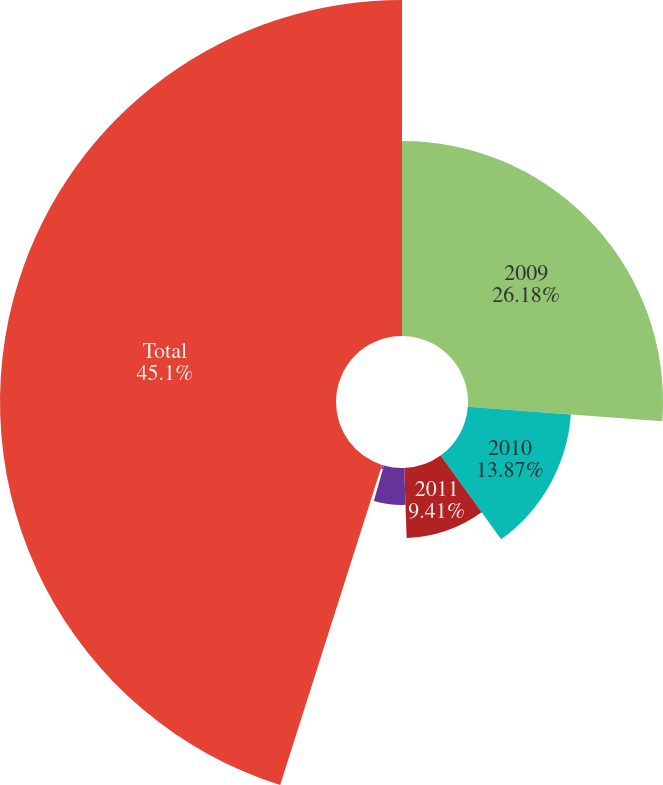Convert chart. <chart><loc_0><loc_0><loc_500><loc_500><pie_chart><fcel>2009<fcel>2010<fcel>2011<fcel>2012<fcel>2013<fcel>Total<nl><fcel>26.17%<fcel>13.87%<fcel>9.41%<fcel>4.95%<fcel>0.49%<fcel>45.09%<nl></chart> 